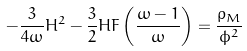<formula> <loc_0><loc_0><loc_500><loc_500>- \frac { 3 } { 4 \omega } H ^ { 2 } - \frac { 3 } { 2 } H F \left ( \frac { \omega - 1 } { \omega } \right ) = \frac { { \rho } _ { M } } { \phi ^ { 2 } }</formula> 